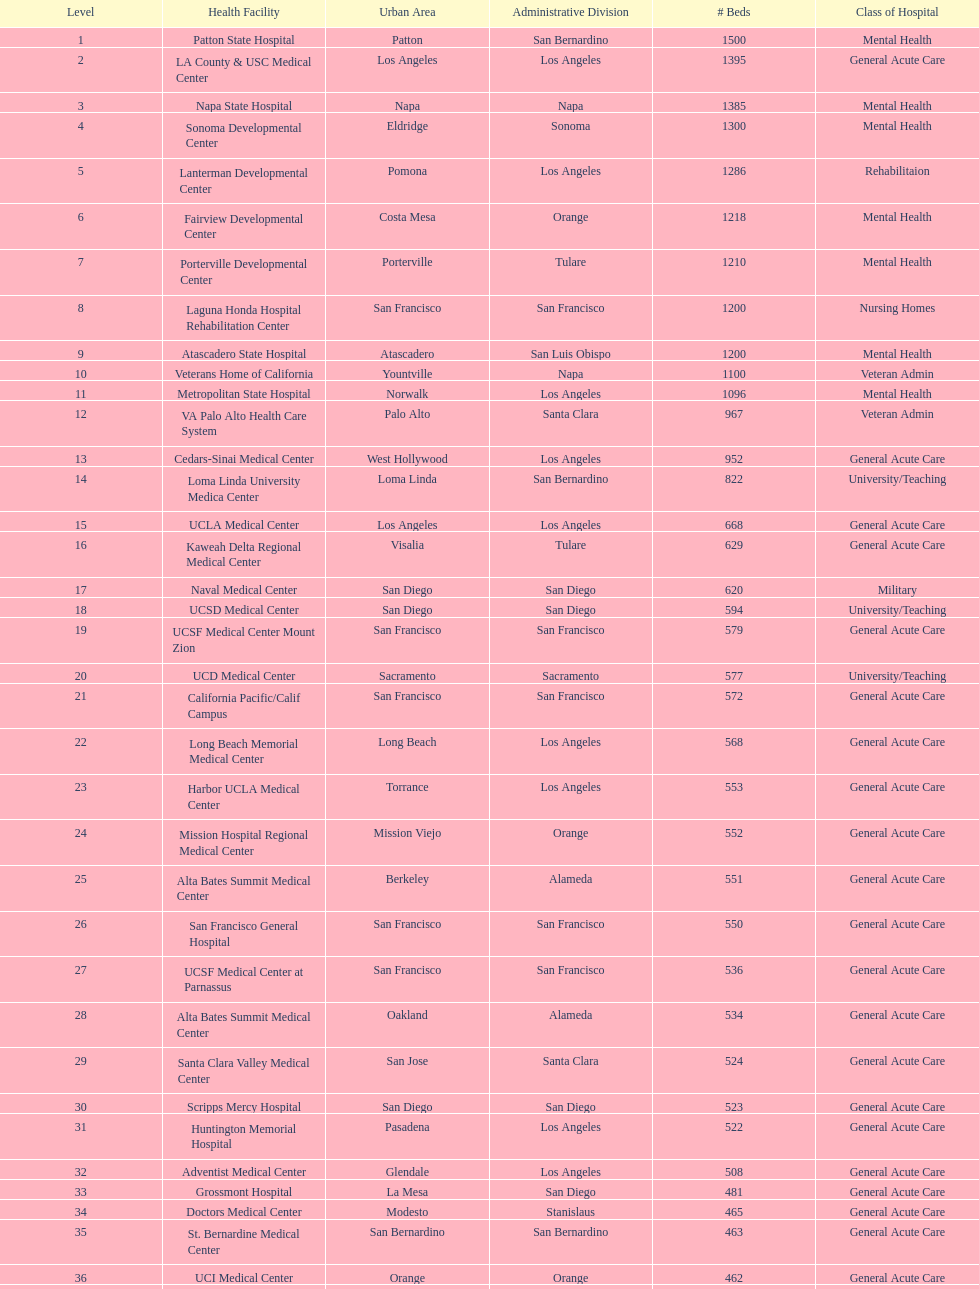How many hospital's have at least 600 beds? 17. 